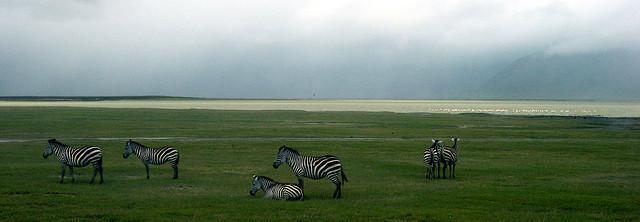How many zebras are looking at the camera?
Give a very brief answer. 0. How many animals are in view?
Give a very brief answer. 6. How many people are wearing a jacket?
Give a very brief answer. 0. 